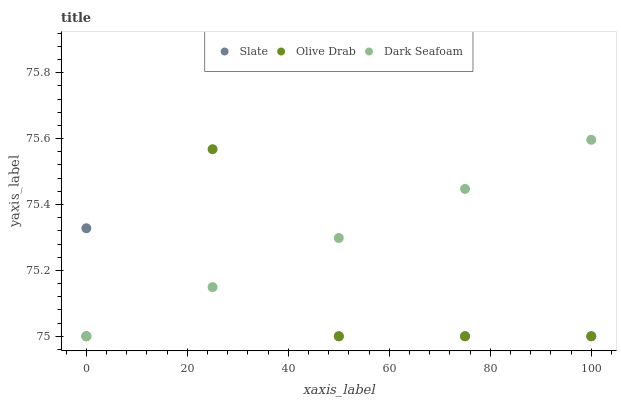Does Olive Drab have the minimum area under the curve?
Answer yes or no. Yes. Does Dark Seafoam have the maximum area under the curve?
Answer yes or no. Yes. Does Dark Seafoam have the minimum area under the curve?
Answer yes or no. No. Does Olive Drab have the maximum area under the curve?
Answer yes or no. No. Is Dark Seafoam the smoothest?
Answer yes or no. Yes. Is Slate the roughest?
Answer yes or no. Yes. Is Olive Drab the smoothest?
Answer yes or no. No. Is Olive Drab the roughest?
Answer yes or no. No. Does Slate have the lowest value?
Answer yes or no. Yes. Does Slate have the highest value?
Answer yes or no. Yes. Does Dark Seafoam have the highest value?
Answer yes or no. No. Does Dark Seafoam intersect Slate?
Answer yes or no. Yes. Is Dark Seafoam less than Slate?
Answer yes or no. No. Is Dark Seafoam greater than Slate?
Answer yes or no. No. 